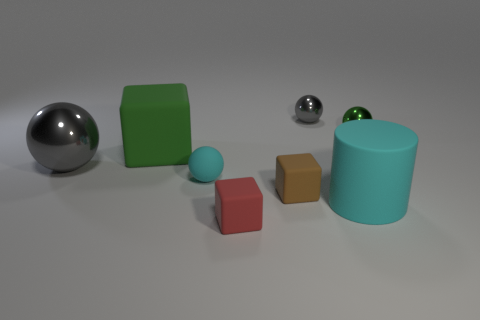Subtract all tiny spheres. How many spheres are left? 1 Add 1 small brown objects. How many objects exist? 9 Subtract 1 balls. How many balls are left? 3 Subtract all red blocks. How many gray balls are left? 2 Subtract all green cubes. How many cubes are left? 2 Subtract all cylinders. How many objects are left? 7 Subtract all small red rubber objects. Subtract all small brown matte blocks. How many objects are left? 6 Add 7 large green matte blocks. How many large green matte blocks are left? 8 Add 7 large red matte things. How many large red matte things exist? 7 Subtract 0 blue cylinders. How many objects are left? 8 